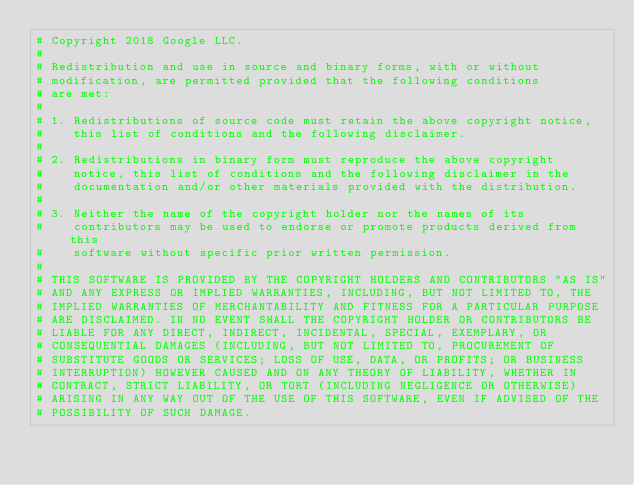<code> <loc_0><loc_0><loc_500><loc_500><_Python_># Copyright 2018 Google LLC.
#
# Redistribution and use in source and binary forms, with or without
# modification, are permitted provided that the following conditions
# are met:
#
# 1. Redistributions of source code must retain the above copyright notice,
#    this list of conditions and the following disclaimer.
#
# 2. Redistributions in binary form must reproduce the above copyright
#    notice, this list of conditions and the following disclaimer in the
#    documentation and/or other materials provided with the distribution.
#
# 3. Neither the name of the copyright holder nor the names of its
#    contributors may be used to endorse or promote products derived from this
#    software without specific prior written permission.
#
# THIS SOFTWARE IS PROVIDED BY THE COPYRIGHT HOLDERS AND CONTRIBUTORS "AS IS"
# AND ANY EXPRESS OR IMPLIED WARRANTIES, INCLUDING, BUT NOT LIMITED TO, THE
# IMPLIED WARRANTIES OF MERCHANTABILITY AND FITNESS FOR A PARTICULAR PURPOSE
# ARE DISCLAIMED. IN NO EVENT SHALL THE COPYRIGHT HOLDER OR CONTRIBUTORS BE
# LIABLE FOR ANY DIRECT, INDIRECT, INCIDENTAL, SPECIAL, EXEMPLARY, OR
# CONSEQUENTIAL DAMAGES (INCLUDING, BUT NOT LIMITED TO, PROCUREMENT OF
# SUBSTITUTE GOODS OR SERVICES; LOSS OF USE, DATA, OR PROFITS; OR BUSINESS
# INTERRUPTION) HOWEVER CAUSED AND ON ANY THEORY OF LIABILITY, WHETHER IN
# CONTRACT, STRICT LIABILITY, OR TORT (INCLUDING NEGLIGENCE OR OTHERWISE)
# ARISING IN ANY WAY OUT OF THE USE OF THIS SOFTWARE, EVEN IF ADVISED OF THE
# POSSIBILITY OF SUCH DAMAGE.

</code> 